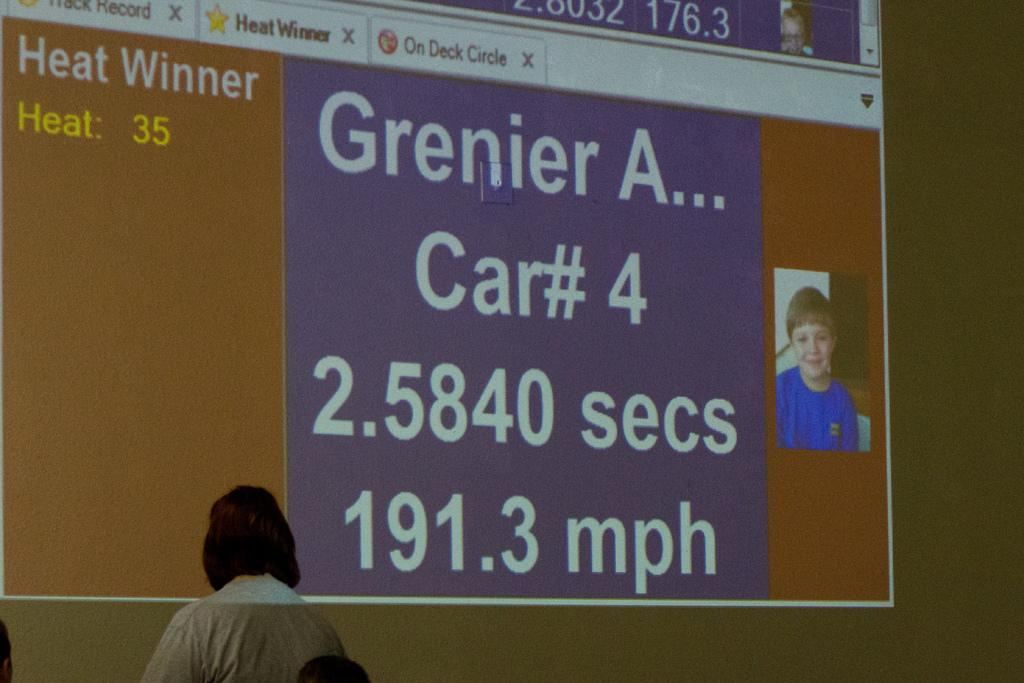What is the main subject of the image? There is a picture of a person in the image. What else can be seen on the screen in the image? There is text on the screen in the image. Can you describe the position of the person in the image? There is a person in the left bottom of the image. What type of straw is being used by the person in the image? There is no straw present in the image. What historical event is depicted in the image? The image does not depict any historical event; it features a picture of a person and text on a screen. 